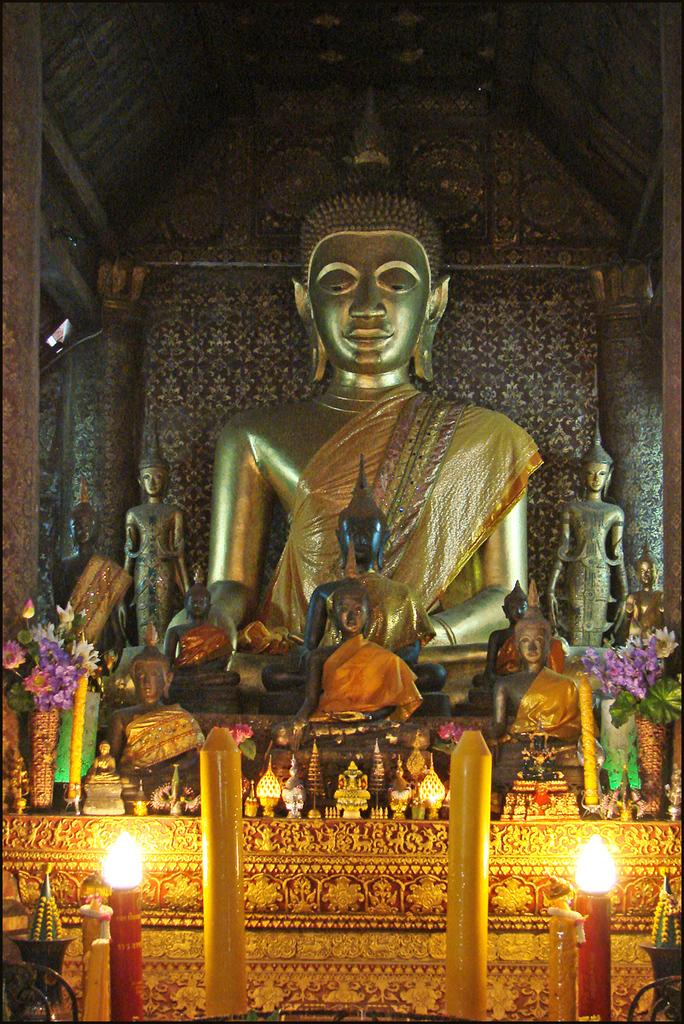What can be seen in the foreground of the image? There are candles and other objects in the foreground of the image. What is the main subject in the center of the image? There are sculptures of persons in the center of the image. What can be seen in the background of the image? There is a wall and a roof in the background of the image. What is the governor's opinion on the learning condition of the sculptures in the image? There is no governor present in the image, and the learning condition of the sculptures is not mentioned. 